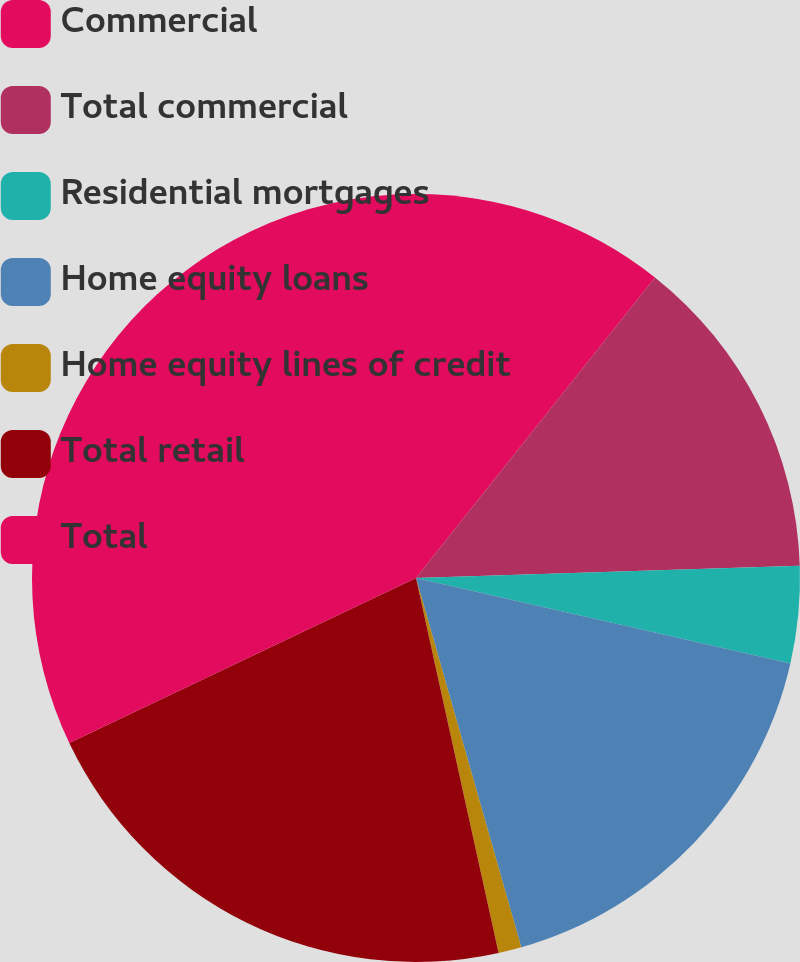Convert chart to OTSL. <chart><loc_0><loc_0><loc_500><loc_500><pie_chart><fcel>Commercial<fcel>Total commercial<fcel>Residential mortgages<fcel>Home equity loans<fcel>Home equity lines of credit<fcel>Total retail<fcel>Total<nl><fcel>10.69%<fcel>13.8%<fcel>4.08%<fcel>17.01%<fcel>0.97%<fcel>21.38%<fcel>32.07%<nl></chart> 